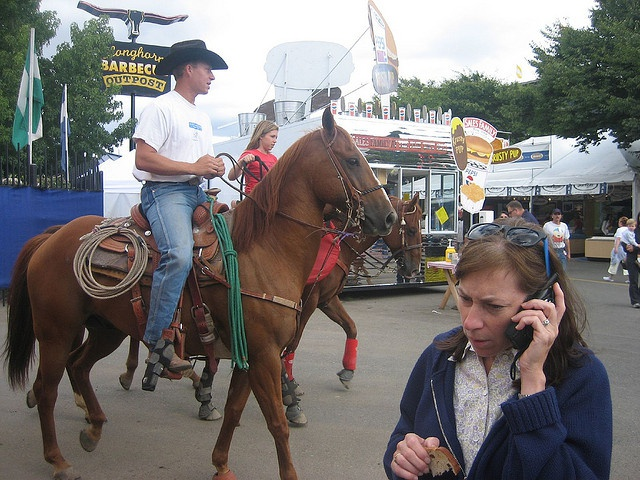Describe the objects in this image and their specific colors. I can see horse in black, maroon, gray, and brown tones, people in black, navy, and gray tones, people in black, white, gray, darkgray, and blue tones, horse in black, maroon, and gray tones, and people in black, brown, gray, darkgray, and salmon tones in this image. 